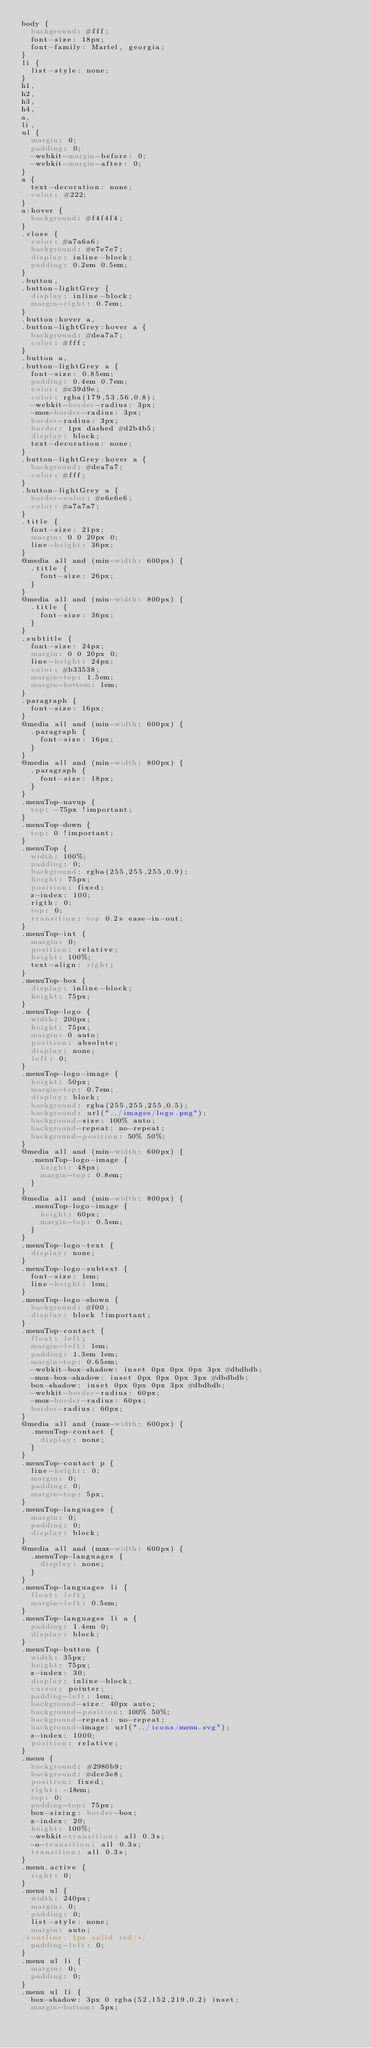Convert code to text. <code><loc_0><loc_0><loc_500><loc_500><_CSS_>body {
  background: #fff;
  font-size: 18px;
  font-family: Martel, georgia;
}
li {
  list-style: none;
}
h1,
h2,
h3,
h4,
a,
li,
ul {
  margin: 0;
  padding: 0;
  -webkit-margin-before: 0;
  -webkit-margin-after: 0;
}
a {
  text-decoration: none;
  color: #222;
}
a:hover {
  background: #f4f4f4;
}
.close {
  color: #a7a6a6;
  background: #e7e7e7;
  display: inline-block;
  padding: 0.2em 0.5em;
}
.button,
.button-lightGrey {
  display: inline-block;
  margin-right: 0.7em;
}
.button:hover a,
.button-lightGrey:hover a {
  background: #dea7a7;
  color: #fff;
}
.button a,
.button-lightGrey a {
  font-size: 0.85em;
  padding: 0.4em 0.7em;
  color: #c39d9e;
  color: rgba(179,53,56,0.8);
  -webkit-border-radius: 3px;
  -moz-border-radius: 3px;
  border-radius: 3px;
  border: 1px dashed #d2b4b5;
  display: block;
  text-decoration: none;
}
.button-lightGrey:hover a {
  background: #dea7a7;
  color: #fff;
}
.button-lightGrey a {
  border-color: #e6e6e6;
  color: #a7a7a7;
}
.title {
  font-size: 21px;
  margin: 0 0 20px 0;
  line-height: 36px;
}
@media all and (min-width: 600px) {
  .title {
    font-size: 26px;
  }
}
@media all and (min-width: 800px) {
  .title {
    font-size: 36px;
  }
}
.subtitle {
  font-size: 24px;
  margin: 0 0 20px 0;
  line-height: 24px;
  color: #b33538;
  margin-top: 1.5em;
  margin-bottom: 1em;
}
.paragraph {
  font-size: 16px;
}
@media all and (min-width: 600px) {
  .paragraph {
    font-size: 16px;
  }
}
@media all and (min-width: 800px) {
  .paragraph {
    font-size: 18px;
  }
}
.menuTop-navup {
  top: -75px !important;
}
.menuTop-down {
  top: 0 !important;
}
.menuTop {
  width: 100%;
  padding: 0;
  background: rgba(255,255,255,0.9);
  height: 75px;
  position: fixed;
  z-index: 100;
  rigth: 0;
  top: 0;
  transition: top 0.2s ease-in-out;
}
.menuTop-int {
  margin: 0;
  position: relative;
  height: 100%;
  text-align: right;
}
.menuTop-box {
  display: inline-block;
  height: 75px;
}
.menuTop-logo {
  width: 200px;
  height: 75px;
  margin: 0 auto;
  position: absolute;
  display: none;
  left: 0;
}
.menuTop-logo-image {
  height: 50px;
  margin-top: 0.7em;
  display: block;
  background: rgba(255,255,255,0.5);
  background: url("../images/logo.png");
  background-size: 100% auto;
  background-repeat: no-repeat;
  background-position: 50% 50%;
}
@media all and (min-width: 600px) {
  .menuTop-logo-image {
    height: 48px;
    margin-top: 0.8em;
  }
}
@media all and (min-width: 800px) {
  .menuTop-logo-image {
    height: 60px;
    margin-top: 0.5em;
  }
}
.menuTop-logo-text {
  display: none;
}
.menuTop-logo-subtext {
  font-size: 1em;
  line-height: 1em;
}
.menuTop-logo-shown {
  background: #f00;
  display: block !important;
}
.menuTop-contact {
  float: left;
  margin-left: 1em;
  padding: 1.3em 1em;
  margin-top: 0.65em;
  -webkit-box-shadow: inset 0px 0px 0px 3px #dbdbdb;
  -moz-box-shadow: inset 0px 0px 0px 3px #dbdbdb;
  box-shadow: inset 0px 0px 0px 3px #dbdbdb;
  -webkit-border-radius: 60px;
  -moz-border-radius: 60px;
  border-radius: 60px;
}
@media all and (max-width: 600px) {
  .menuTop-contact {
    display: none;
  }
}
.menuTop-contact p {
  line-height: 0;
  margin: 0;
  padding: 0;
  margin-top: 5px;
}
.menuTop-languages {
  margin: 0;
  padding: 0;
  display: block;
}
@media all and (max-width: 600px) {
  .menuTop-languages {
    display: none;
  }
}
.menuTop-languages li {
  float: left;
  margin-left: 0.5em;
}
.menuTop-languages li a {
  padding: 1.4em 0;
  display: block;
}
.menuTop-button {
  width: 35px;
  height: 75px;
  z-index: 30;
  display: inline-block;
  cursor: pointer;
  padding-left: 1em;
  background-size: 40px auto;
  background-position: 100% 50%;
  background-repeat: no-repeat;
  background-image: url("../icons/menu.svg");
  z-index: 1000;
  position: relative;
}
.menu {
  background: #2980b9;
  background: #dce3e8;
  position: fixed;
  right: -18em;
  top: 0;
  padding-top: 75px;
  box-sizing: border-box;
  z-index: 20;
  height: 100%;
  -webkit-transition: all 0.3s;
  -o-transition: all 0.3s;
  transition: all 0.3s;
}
.menu.active {
  right: 0;
}
.menu ul {
  width: 240px;
  margin: 0;
  padding: 0;
  list-style: none;
  margin: auto;
/*outline: 1px solid red;*/
  padding-left: 0;
}
.menu ul li {
  margin: 0;
  padding: 0;
}
.menu ul li {
  box-shadow: 3px 0 rgba(52,152,219,0.2) inset;
  margin-bottom: 5px;</code> 